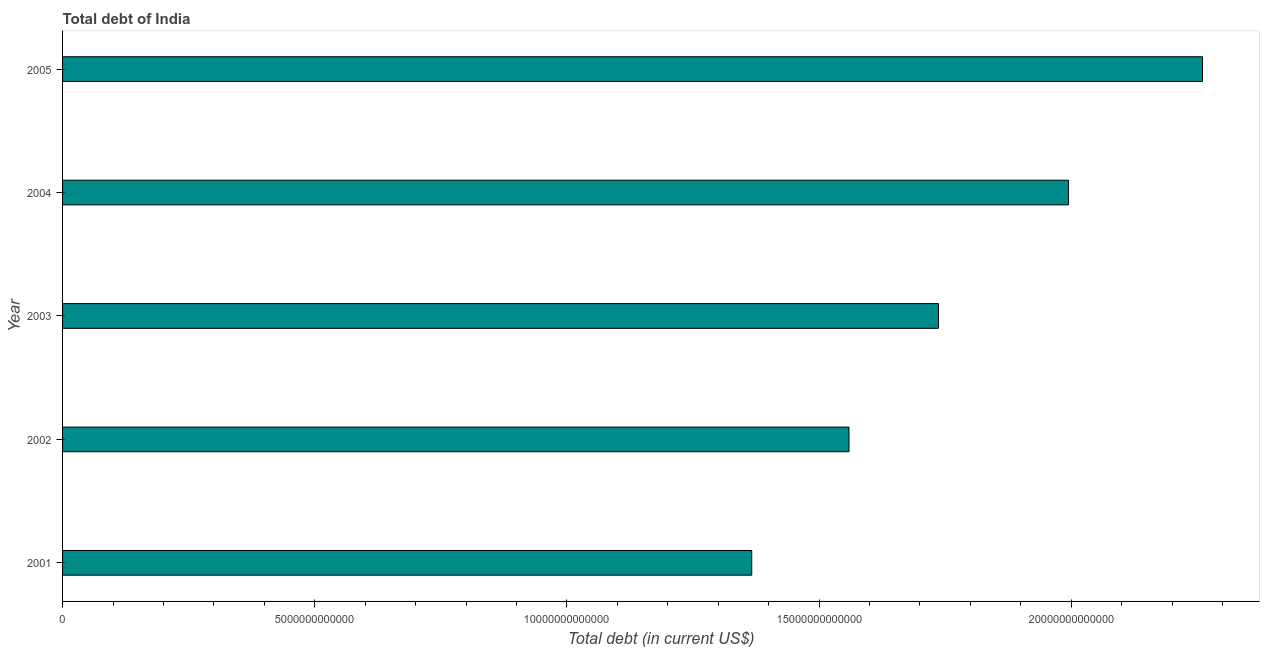What is the title of the graph?
Make the answer very short. Total debt of India. What is the label or title of the X-axis?
Provide a short and direct response. Total debt (in current US$). What is the total debt in 2002?
Offer a terse response. 1.56e+13. Across all years, what is the maximum total debt?
Give a very brief answer. 2.26e+13. Across all years, what is the minimum total debt?
Give a very brief answer. 1.37e+13. In which year was the total debt maximum?
Provide a succinct answer. 2005. In which year was the total debt minimum?
Make the answer very short. 2001. What is the sum of the total debt?
Make the answer very short. 8.92e+13. What is the difference between the total debt in 2001 and 2005?
Your answer should be very brief. -8.94e+12. What is the average total debt per year?
Make the answer very short. 1.78e+13. What is the median total debt?
Your answer should be compact. 1.74e+13. What is the ratio of the total debt in 2001 to that in 2004?
Give a very brief answer. 0.69. Is the total debt in 2002 less than that in 2003?
Your response must be concise. Yes. Is the difference between the total debt in 2001 and 2002 greater than the difference between any two years?
Your answer should be compact. No. What is the difference between the highest and the second highest total debt?
Provide a short and direct response. 2.66e+12. Is the sum of the total debt in 2002 and 2003 greater than the maximum total debt across all years?
Your response must be concise. Yes. What is the difference between the highest and the lowest total debt?
Make the answer very short. 8.94e+12. In how many years, is the total debt greater than the average total debt taken over all years?
Offer a very short reply. 2. Are all the bars in the graph horizontal?
Make the answer very short. Yes. What is the difference between two consecutive major ticks on the X-axis?
Give a very brief answer. 5.00e+12. Are the values on the major ticks of X-axis written in scientific E-notation?
Provide a short and direct response. No. What is the Total debt (in current US$) of 2001?
Your answer should be compact. 1.37e+13. What is the Total debt (in current US$) in 2002?
Provide a short and direct response. 1.56e+13. What is the Total debt (in current US$) in 2003?
Your response must be concise. 1.74e+13. What is the Total debt (in current US$) of 2004?
Offer a terse response. 1.99e+13. What is the Total debt (in current US$) of 2005?
Your answer should be very brief. 2.26e+13. What is the difference between the Total debt (in current US$) in 2001 and 2002?
Provide a succinct answer. -1.93e+12. What is the difference between the Total debt (in current US$) in 2001 and 2003?
Make the answer very short. -3.70e+12. What is the difference between the Total debt (in current US$) in 2001 and 2004?
Your answer should be compact. -6.28e+12. What is the difference between the Total debt (in current US$) in 2001 and 2005?
Keep it short and to the point. -8.94e+12. What is the difference between the Total debt (in current US$) in 2002 and 2003?
Ensure brevity in your answer.  -1.77e+12. What is the difference between the Total debt (in current US$) in 2002 and 2004?
Your answer should be compact. -4.35e+12. What is the difference between the Total debt (in current US$) in 2002 and 2005?
Your answer should be very brief. -7.01e+12. What is the difference between the Total debt (in current US$) in 2003 and 2004?
Provide a succinct answer. -2.58e+12. What is the difference between the Total debt (in current US$) in 2003 and 2005?
Keep it short and to the point. -5.23e+12. What is the difference between the Total debt (in current US$) in 2004 and 2005?
Your answer should be compact. -2.66e+12. What is the ratio of the Total debt (in current US$) in 2001 to that in 2002?
Offer a very short reply. 0.88. What is the ratio of the Total debt (in current US$) in 2001 to that in 2003?
Keep it short and to the point. 0.79. What is the ratio of the Total debt (in current US$) in 2001 to that in 2004?
Offer a terse response. 0.69. What is the ratio of the Total debt (in current US$) in 2001 to that in 2005?
Your answer should be compact. 0.6. What is the ratio of the Total debt (in current US$) in 2002 to that in 2003?
Make the answer very short. 0.9. What is the ratio of the Total debt (in current US$) in 2002 to that in 2004?
Offer a terse response. 0.78. What is the ratio of the Total debt (in current US$) in 2002 to that in 2005?
Provide a succinct answer. 0.69. What is the ratio of the Total debt (in current US$) in 2003 to that in 2004?
Your answer should be compact. 0.87. What is the ratio of the Total debt (in current US$) in 2003 to that in 2005?
Provide a succinct answer. 0.77. What is the ratio of the Total debt (in current US$) in 2004 to that in 2005?
Ensure brevity in your answer.  0.88. 